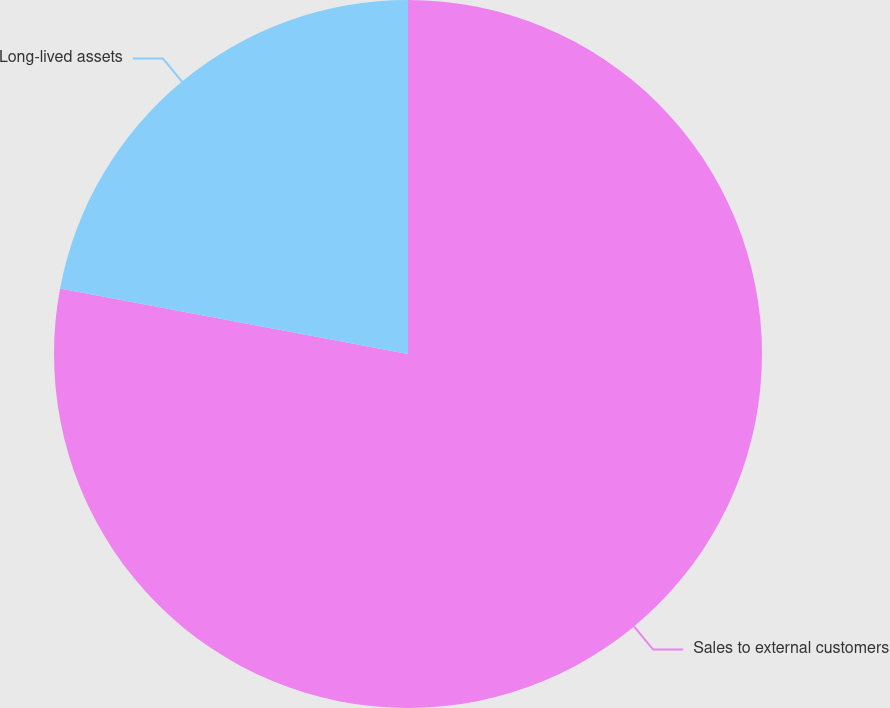Convert chart to OTSL. <chart><loc_0><loc_0><loc_500><loc_500><pie_chart><fcel>Sales to external customers<fcel>Long-lived assets<nl><fcel>77.96%<fcel>22.04%<nl></chart> 